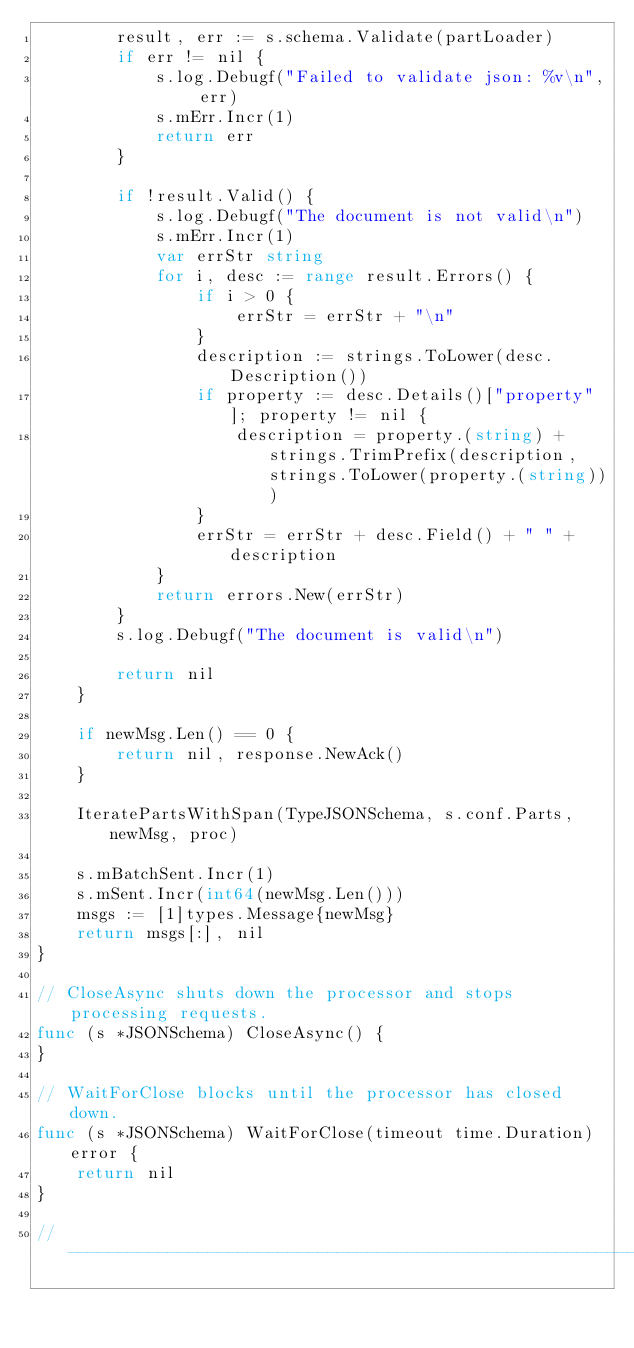<code> <loc_0><loc_0><loc_500><loc_500><_Go_>		result, err := s.schema.Validate(partLoader)
		if err != nil {
			s.log.Debugf("Failed to validate json: %v\n", err)
			s.mErr.Incr(1)
			return err
		}

		if !result.Valid() {
			s.log.Debugf("The document is not valid\n")
			s.mErr.Incr(1)
			var errStr string
			for i, desc := range result.Errors() {
				if i > 0 {
					errStr = errStr + "\n"
				}
				description := strings.ToLower(desc.Description())
				if property := desc.Details()["property"]; property != nil {
					description = property.(string) + strings.TrimPrefix(description, strings.ToLower(property.(string)))
				}
				errStr = errStr + desc.Field() + " " + description
			}
			return errors.New(errStr)
		}
		s.log.Debugf("The document is valid\n")

		return nil
	}

	if newMsg.Len() == 0 {
		return nil, response.NewAck()
	}

	IteratePartsWithSpan(TypeJSONSchema, s.conf.Parts, newMsg, proc)

	s.mBatchSent.Incr(1)
	s.mSent.Incr(int64(newMsg.Len()))
	msgs := [1]types.Message{newMsg}
	return msgs[:], nil
}

// CloseAsync shuts down the processor and stops processing requests.
func (s *JSONSchema) CloseAsync() {
}

// WaitForClose blocks until the processor has closed down.
func (s *JSONSchema) WaitForClose(timeout time.Duration) error {
	return nil
}

//------------------------------------------------------------------------------
</code> 